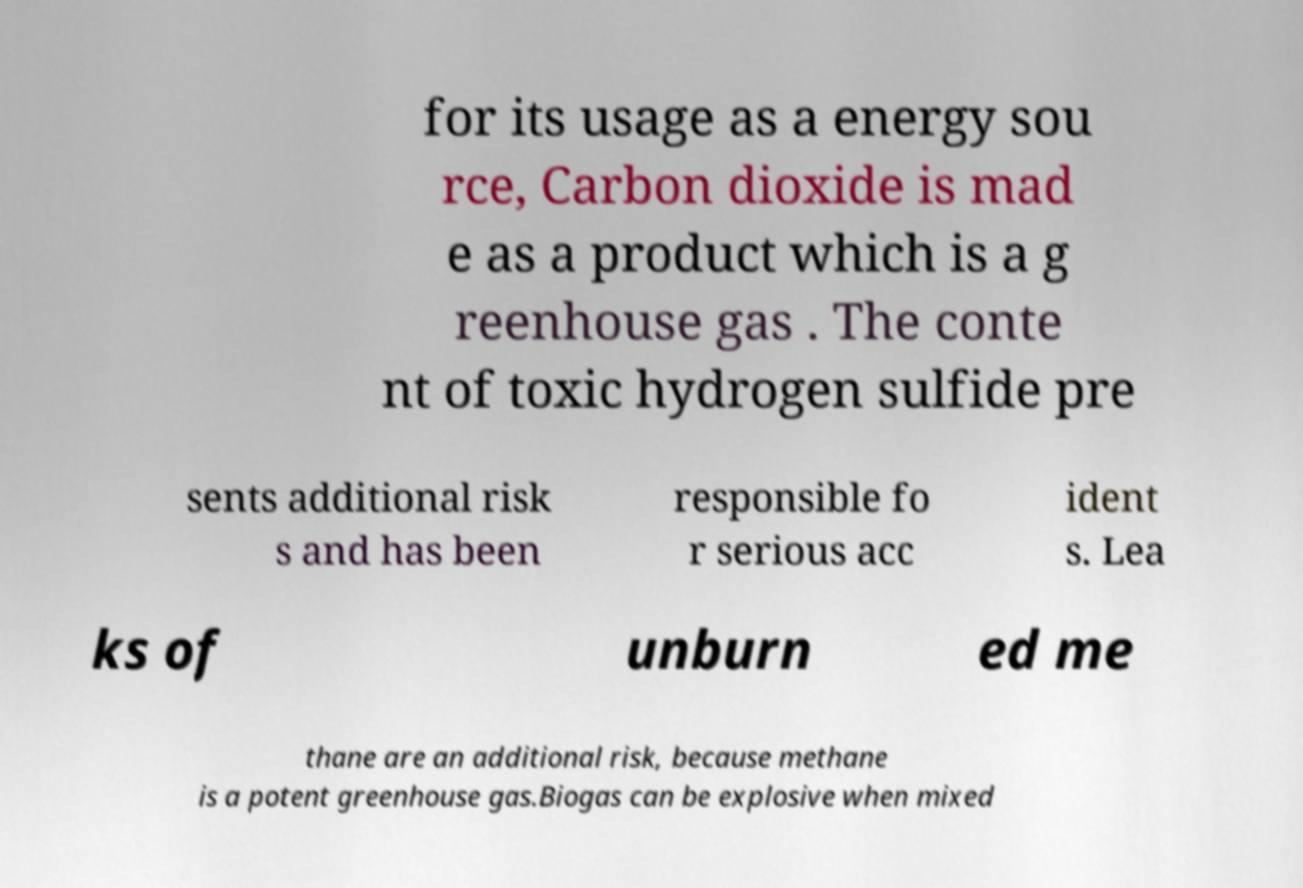Please identify and transcribe the text found in this image. for its usage as a energy sou rce, Carbon dioxide is mad e as a product which is a g reenhouse gas . The conte nt of toxic hydrogen sulfide pre sents additional risk s and has been responsible fo r serious acc ident s. Lea ks of unburn ed me thane are an additional risk, because methane is a potent greenhouse gas.Biogas can be explosive when mixed 